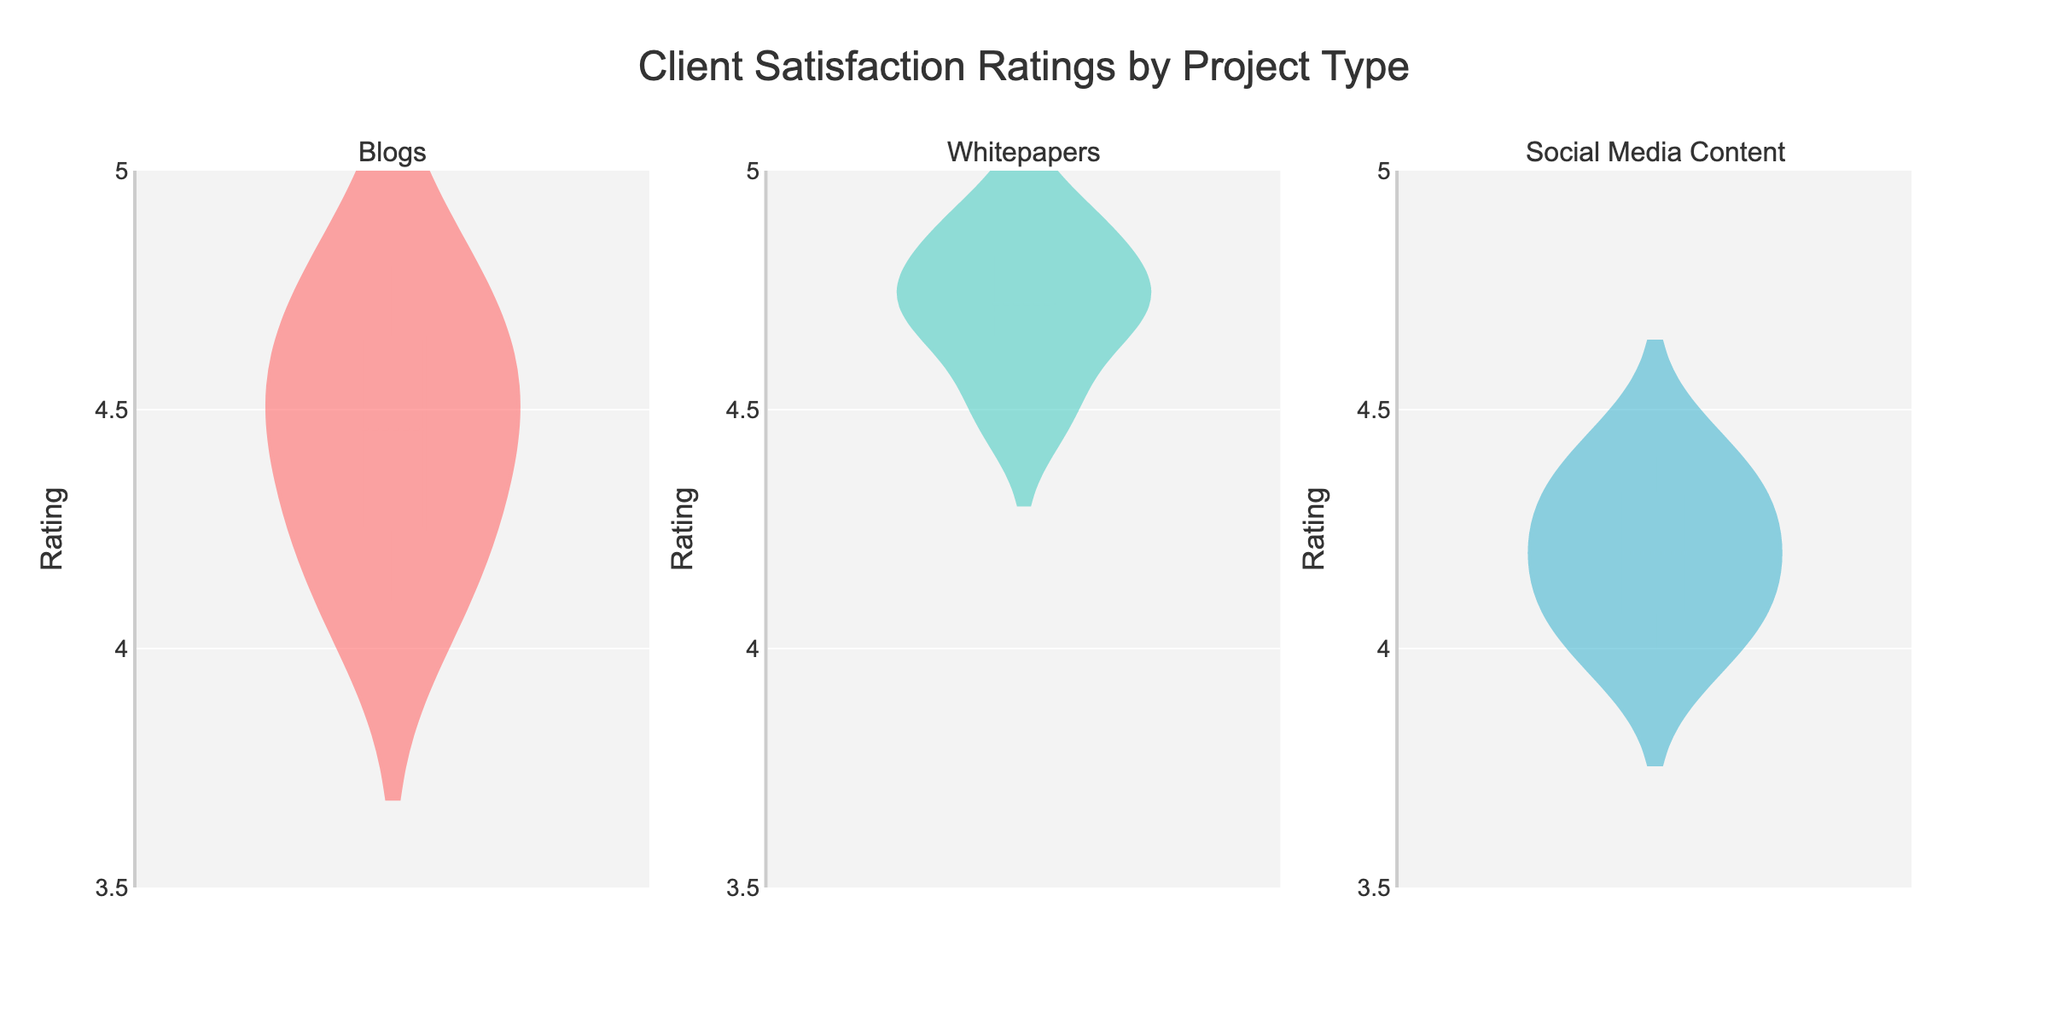what is the title of the figure? The title is shown at the top center of the figure in a larger font size, which reads "Client Satisfaction Ratings by Project Type".
Answer: Client Satisfaction Ratings by Project Type what is the range of ratings on the y-axis? The y-axis range can be observed from the labeled ticks, which start at 3.5 and go up to 5.0.
Answer: 3.5 to 5.0 which project type has the highest mean rating? The mean rating is indicated by a solid line within each violin plot. Comparing the positions of these lines, the "whitepapers" project type has the highest mean rating.
Answer: whitepapers how do the median ratings for blogs and social media content compare? The median is shown as a line within the violin plot. For both "blogs" and "social media content", the median lines can be compared directly. The median rating of "blogs" appears higher than that of "social media content".
Answer: blogs is higher what is the range of ratings for whitepapers? Observing the "whitepapers" violin plot, the range can be seen from its lower to upper bounds. It ranges from approximately 4.5 to 4.9.
Answer: 4.5 to 4.9 which project type has the most spread in client ratings? The spread in ratings can be seen by the width of the violin plot. "Blogs" has a wider spread compared to "whitepapers" and "social media content".
Answer: blogs are there any outliers in the violin plots? Outliers would typically be depicted as individual points outside the main body of the violin plot. None of the violin plots show clear outliers.
Answer: no how many project types are depicted in the subplot? The figure title mentions three specific project types, and these are also depicted as separate subplots labeled "Blogs", "Whitepapers", and "Social Media Content".
Answer: 3 which project type shows the least variation in ratings? Variation is shown by the width and overall shape of the violin plot. "Whitepapers" shows the least variation with a narrower distribution.
Answer: whitepapers what is the median rating for social media content? The median is represented by the line inside the "social media content" violin plot. The median rating can be observed directly and is close to 4.1.
Answer: 4.1 